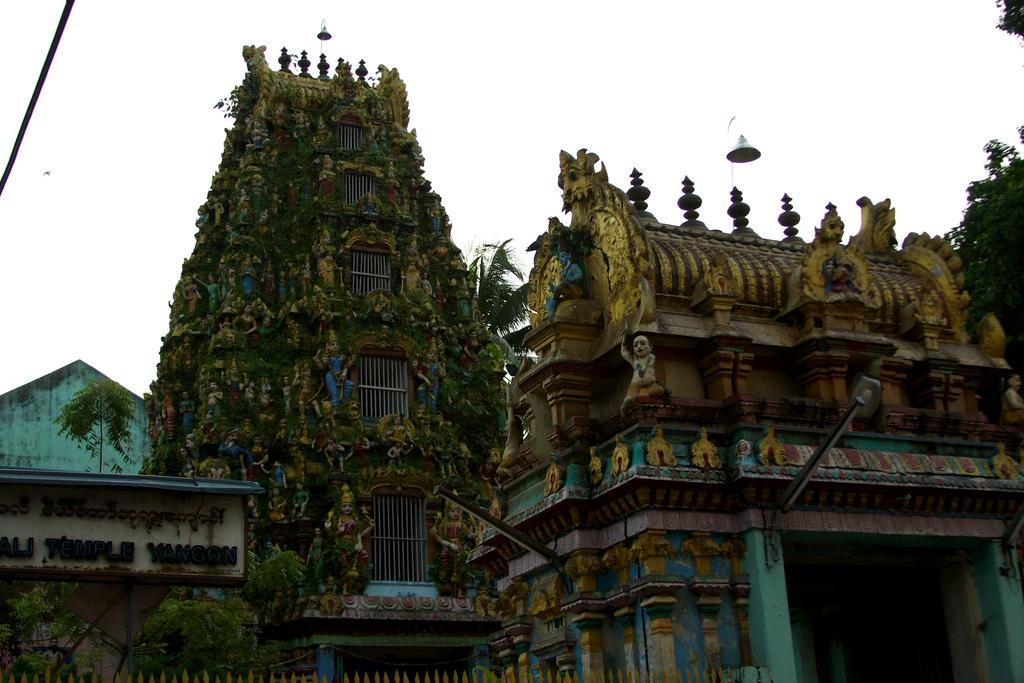What type of structure is visible in the picture? There is an arch of a temple in the picture. What else can be seen in the picture besides the temple? There is a board, lamps, trees, and the sky visible in the picture. Can you describe the lighting in the picture? The presence of lamps suggests that there is artificial lighting in the picture. What is visible in the background of the picture? The sky is visible in the background of the picture. What type of anger can be seen on the ghost's face in the picture? There is no ghost present in the picture, and therefore no anger can be observed. What tool is being used by the wrench in the picture? There is no wrench present in the picture. 